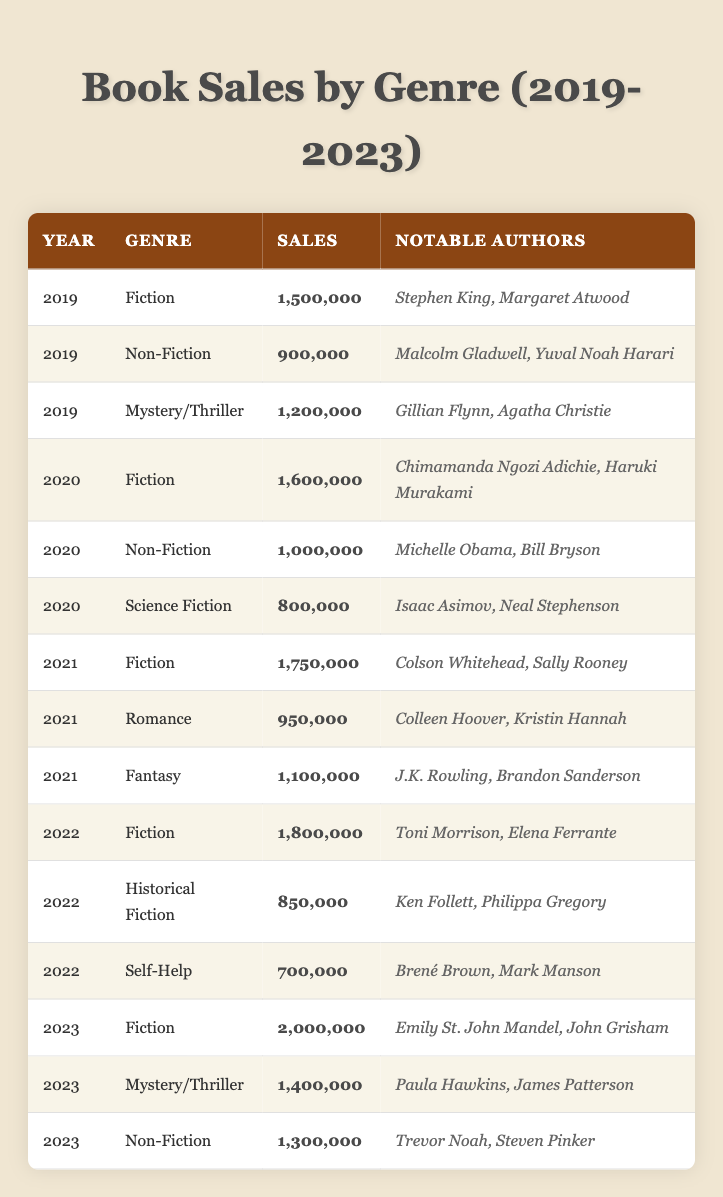What was the highest-selling genre in 2023? The table shows that the Fiction genre had the highest sales in 2023 with 2,000,000 units sold.
Answer: Fiction How many notable authors are associated with the Fiction genre in 2022? The table indicates that in 2022, the Fiction genre had notable authors Toni Morrison and Elena Ferrante, totaling two authors.
Answer: 2 What genre had the lowest sales in 2020? From the table data, the Science Fiction genre had the lowest sales in 2020 with 800,000 units sold.
Answer: Science Fiction What was the total sales of Non-Fiction over the past five years? Adding the Non-Fiction sales from each year gives us: 900,000 (2019) + 1,000,000 (2020) + 1,300,000 (2023) = 3,200,000, and the year 2021 isn't applicable since there's no Non-Fiction, total for 2022 is 0, which means it’s 3,200,000.
Answer: 3,200,000 Which genre experienced the most significant increase in sales from 2019 to 2023? The sales for Fiction in 2019 were 1,500,000, and in 2023, they were 2,000,000. The increase is 500,000, the highest among all genres during that period. Other genres like Mystery/Thriller and Non-Fiction had smaller increases.
Answer: Fiction Was there a year when Romance sales were higher than Mystery/Thriller? Examining the data, Romance sales were 950,000 in 2021 while Mystery/Thriller sales in the same year were 1,200,000. Thus, there was no year Romance sales surpassed Mystery/Thriller sales.
Answer: No How does the average sales of Fantasy compare to that of Historical Fiction from 2019-2023? Calculate the averages: Fantasy has only one year (2021) with sales of 1,100,000 and Historical Fiction in 2022 with 850,000. The average for Fantasy is 1,100,000. So, Fantasy sales were higher than Historical Fiction.
Answer: Fantasy is higher What is the difference in sales between Fiction and Non-Fiction in 2022? In 2022, Fiction had 1,800,000 sales while Non-Fiction sales were not present. Therefore, the difference in this case is essentially Fiction sales, because there are no Non-Fiction sales in 2022.
Answer: 1,800,000 Which genre had the largest number of notable authors in 2021? In 2021, both Fiction (2 authors), Romance (2 authors), and Fantasy (2 authors) had the same number of notable authors. Thus, counting them shows that there’s a tie.
Answer: Fiction, Romance, Fantasy (tie) What overall trend can be observed in Fiction sales from 2019 to 2023? The sales for Fiction demonstrated a consistent increase each year, moving from 1,500,000 in 2019 up to 2,000,000 in 2023, suggesting a growing popularity.
Answer: Increasing trend 